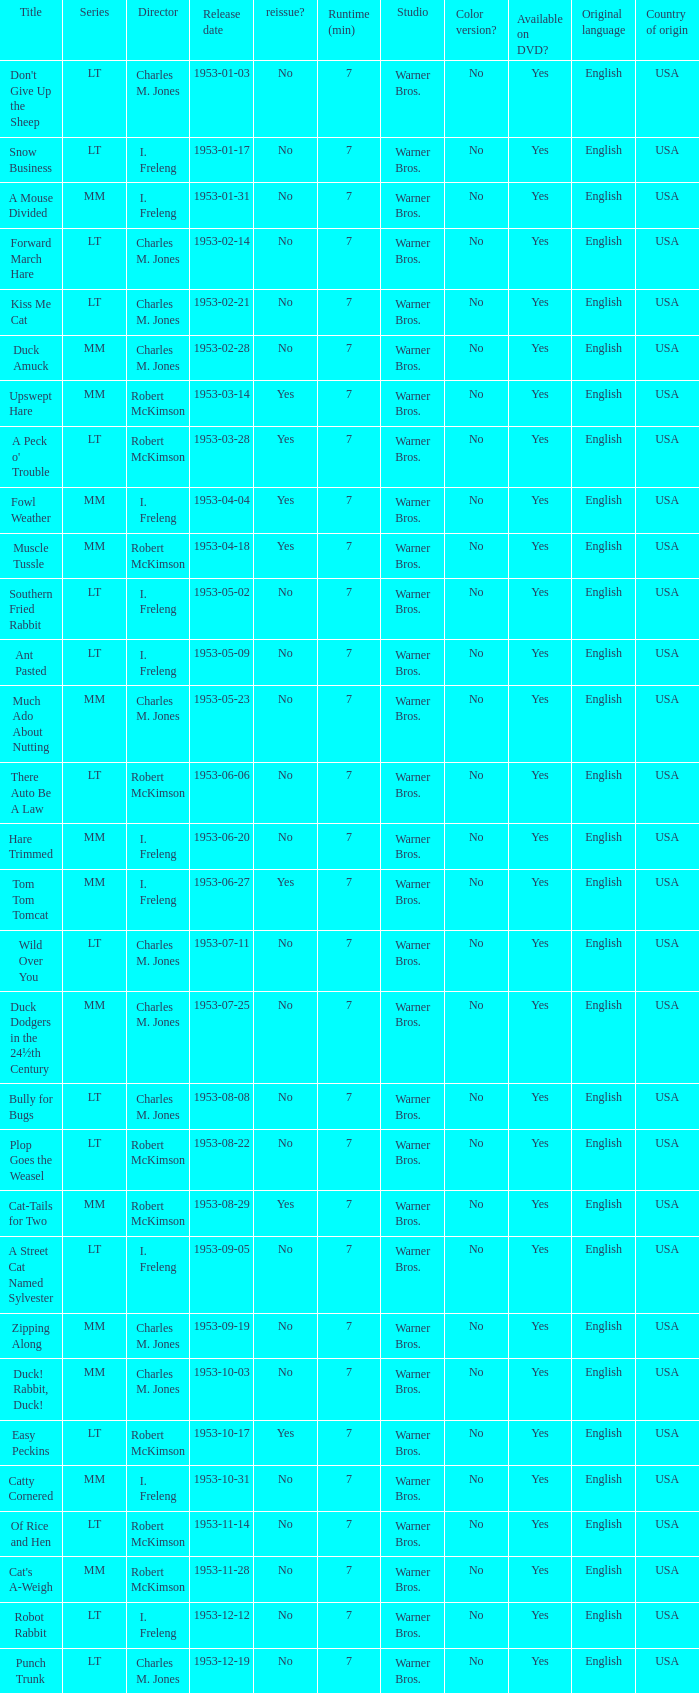What's the release date of Upswept Hare? 1953-03-14. 